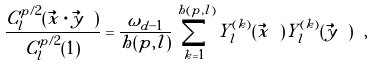Convert formula to latex. <formula><loc_0><loc_0><loc_500><loc_500>\frac { C _ { l } ^ { p / 2 } ( \vec { x } \cdot \vec { y } \ ) } { C _ { l } ^ { p / 2 } ( 1 ) } = \frac { \omega _ { d - 1 } } { h ( p , l ) } \sum _ { k = 1 } ^ { h ( p , l ) } Y _ { l } ^ { ( k ) } ( \vec { x } \ ) Y _ { l } ^ { ( k ) } ( \vec { y } \ ) \ ,</formula> 